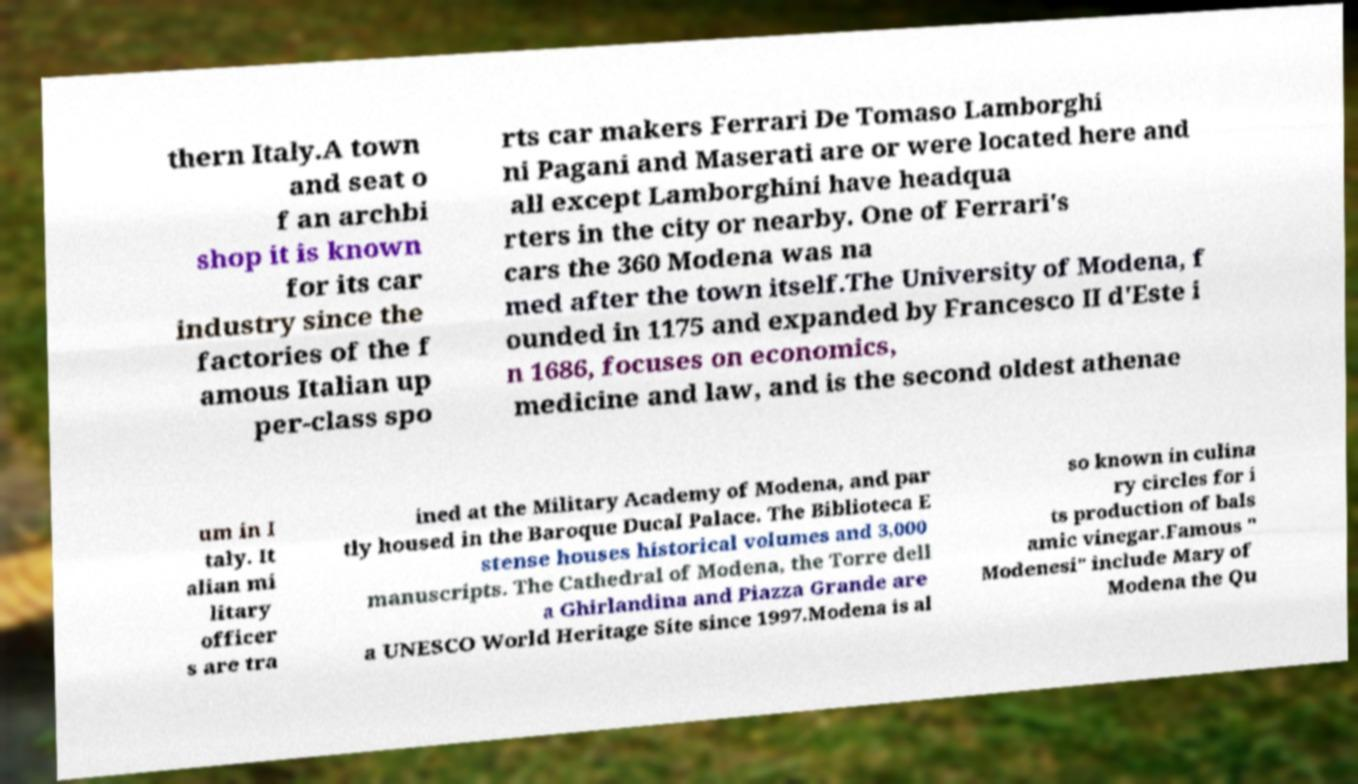I need the written content from this picture converted into text. Can you do that? thern Italy.A town and seat o f an archbi shop it is known for its car industry since the factories of the f amous Italian up per-class spo rts car makers Ferrari De Tomaso Lamborghi ni Pagani and Maserati are or were located here and all except Lamborghini have headqua rters in the city or nearby. One of Ferrari's cars the 360 Modena was na med after the town itself.The University of Modena, f ounded in 1175 and expanded by Francesco II d'Este i n 1686, focuses on economics, medicine and law, and is the second oldest athenae um in I taly. It alian mi litary officer s are tra ined at the Military Academy of Modena, and par tly housed in the Baroque Ducal Palace. The Biblioteca E stense houses historical volumes and 3,000 manuscripts. The Cathedral of Modena, the Torre dell a Ghirlandina and Piazza Grande are a UNESCO World Heritage Site since 1997.Modena is al so known in culina ry circles for i ts production of bals amic vinegar.Famous " Modenesi" include Mary of Modena the Qu 